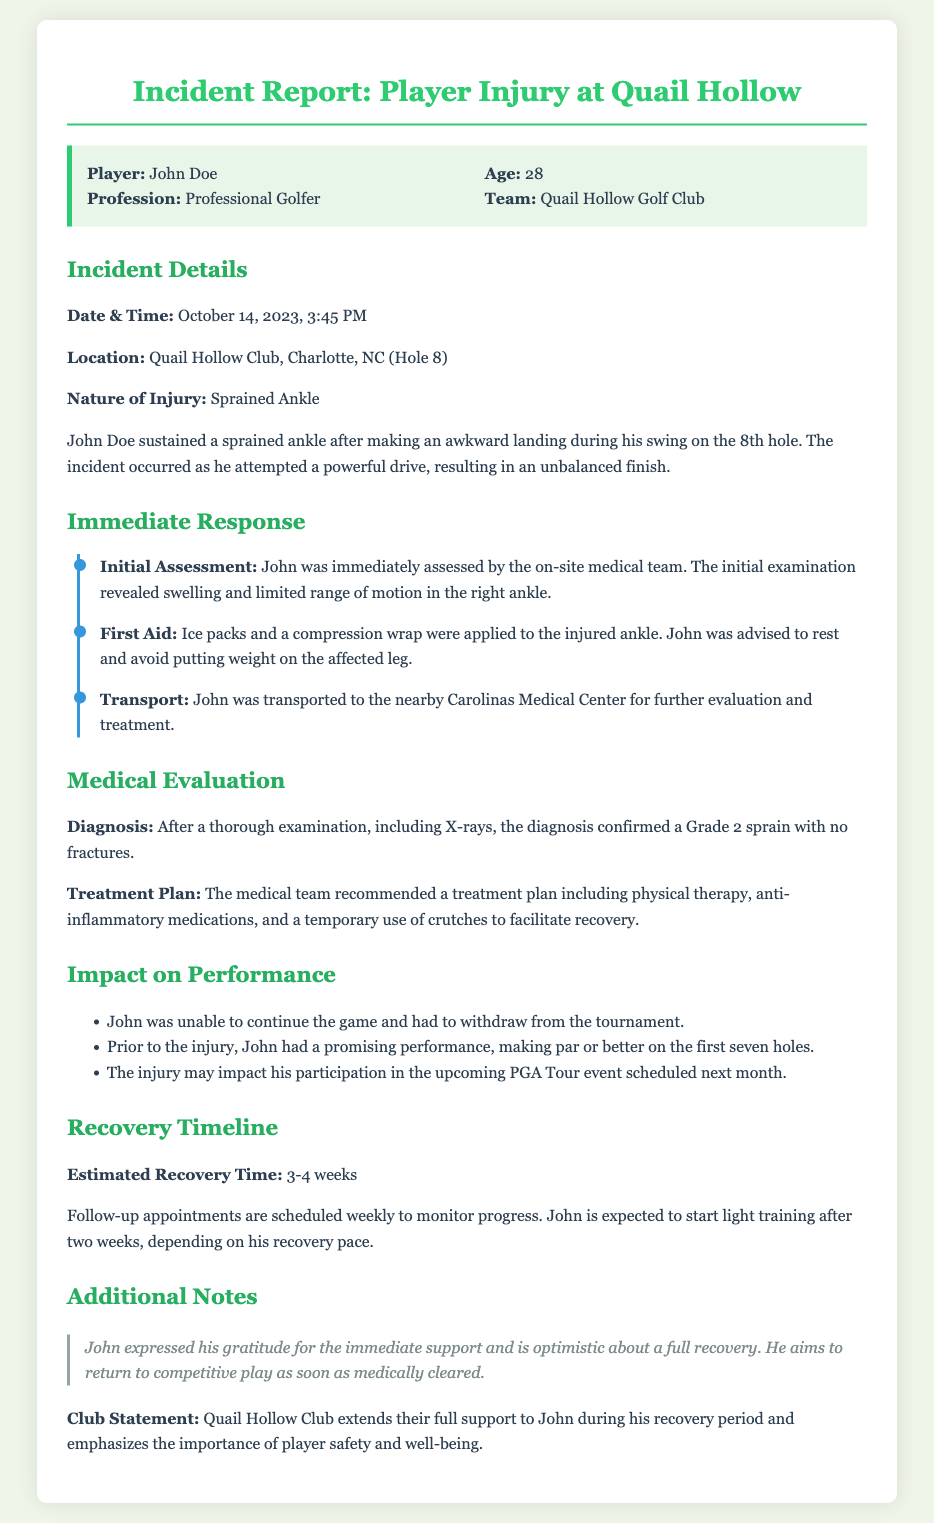What is the date of the incident? The date of the incident is clearly stated in the document under "Incident Details."
Answer: October 14, 2023 What type of injury did John Doe sustain? The nature of the injury is specified in the "Nature of Injury" section of the document.
Answer: Sprained Ankle What was applied to the injured ankle for first aid? The first aid measures are described in the "Immediate Response" section, detailing what treatments were provided initially.
Answer: Ice packs and a compression wrap How long is the estimated recovery time? The "Recovery Timeline" section provides the estimated recovery duration for John Doe's injury.
Answer: 3-4 weeks What was John Doe's performance before the injury? The performance details prior to the injury are mentioned in the "Impact on Performance" section, reflecting his gameplay.
Answer: Making par or better on the first seven holes What was the diagnosis confirmed by the medical team? The diagnosis is noted under "Medical Evaluation," summarizing the findings after further examinations.
Answer: Grade 2 sprain with no fractures What does John aim for regarding his competitive play? John’s aspirations regarding his return to competition are highlighted in the "Additional Notes" section of the report.
Answer: Return to competitive play as soon as medically cleared What support does the Quail Hollow Club extend to John? The club's statement in the report indicates their stance on player safety in support of John during recovery.
Answer: Full support during recovery period 